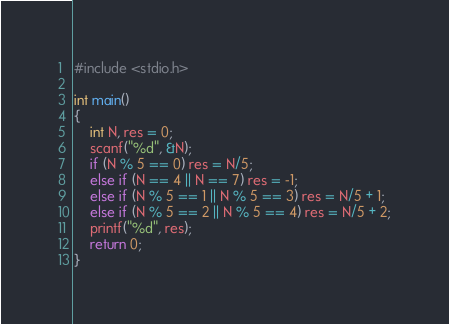<code> <loc_0><loc_0><loc_500><loc_500><_C_>#include <stdio.h>

int main()
{
    int N, res = 0;
    scanf("%d", &N);
    if (N % 5 == 0) res = N/5;
    else if (N == 4 || N == 7) res = -1;
    else if (N % 5 == 1 || N % 5 == 3) res = N/5 + 1;
    else if (N % 5 == 2 || N % 5 == 4) res = N/5 + 2;
    printf("%d", res);
    return 0;
}</code> 